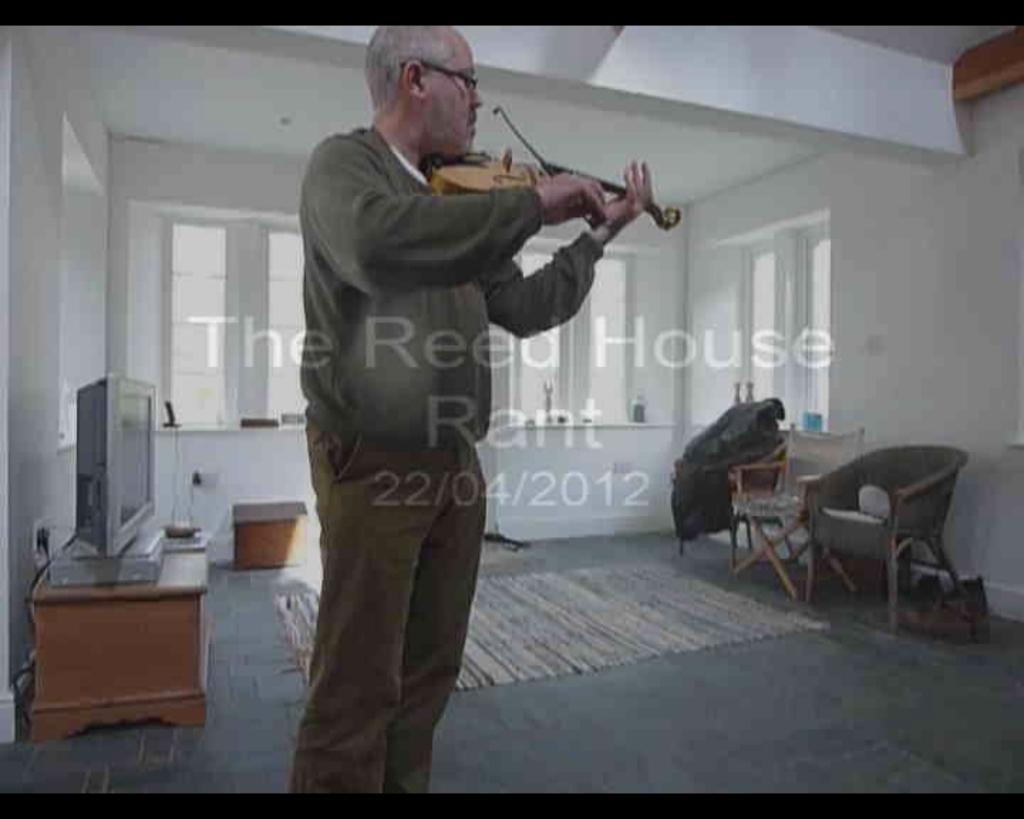How would you summarize this image in a sentence or two? In this image I can see a person standing wearing gray shirt, brown pant holding a guitar. Background I can see a television on a cupboard, few chairs, windows and wall is in white color. 